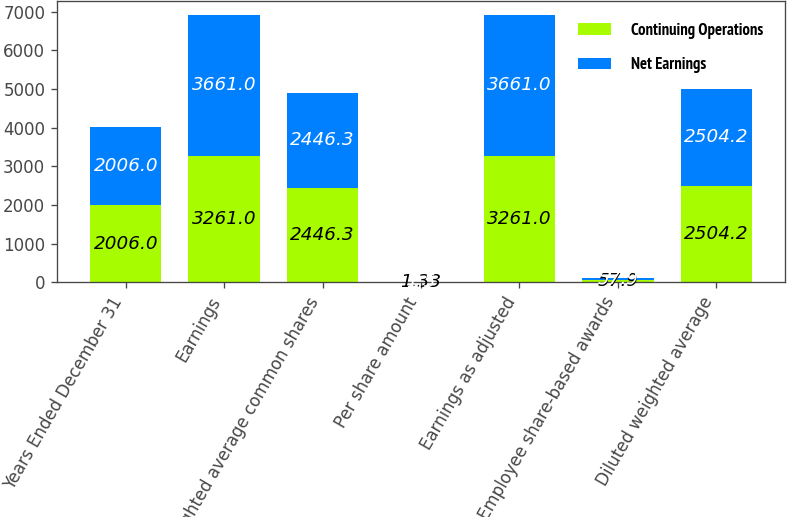Convert chart to OTSL. <chart><loc_0><loc_0><loc_500><loc_500><stacked_bar_chart><ecel><fcel>Years Ended December 31<fcel>Earnings<fcel>Weighted average common shares<fcel>Per share amount<fcel>Earnings as adjusted<fcel>Employee share-based awards<fcel>Diluted weighted average<nl><fcel>Continuing Operations<fcel>2006<fcel>3261<fcel>2446.3<fcel>1.33<fcel>3261<fcel>57.9<fcel>2504.2<nl><fcel>Net Earnings<fcel>2006<fcel>3661<fcel>2446.3<fcel>1.5<fcel>3661<fcel>57.9<fcel>2504.2<nl></chart> 